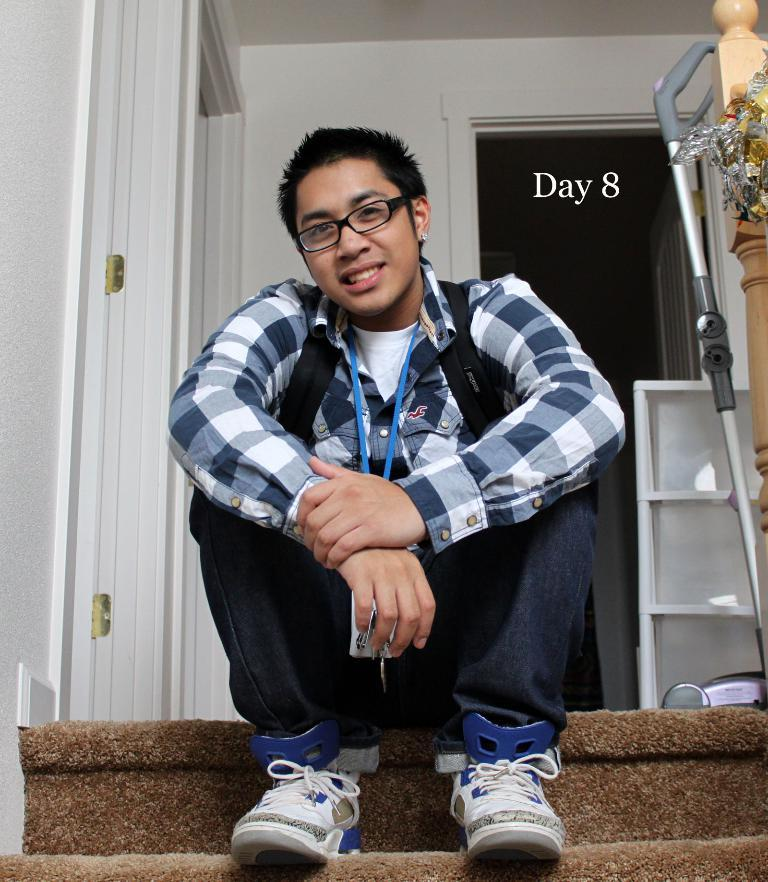What is the person in the image doing? The person is sitting in the image. What can be seen on the person's clothing? The person is wearing an ID card. What type of accessory is the person wearing on their face? The person is wearing spectacles. What is visible in the background of the image? There is a wall in the background of the image. What type of tank can be seen in the image? There is no tank present in the image. How is the person's hat positioned on their head in the image? The person is not wearing a hat in the image. 